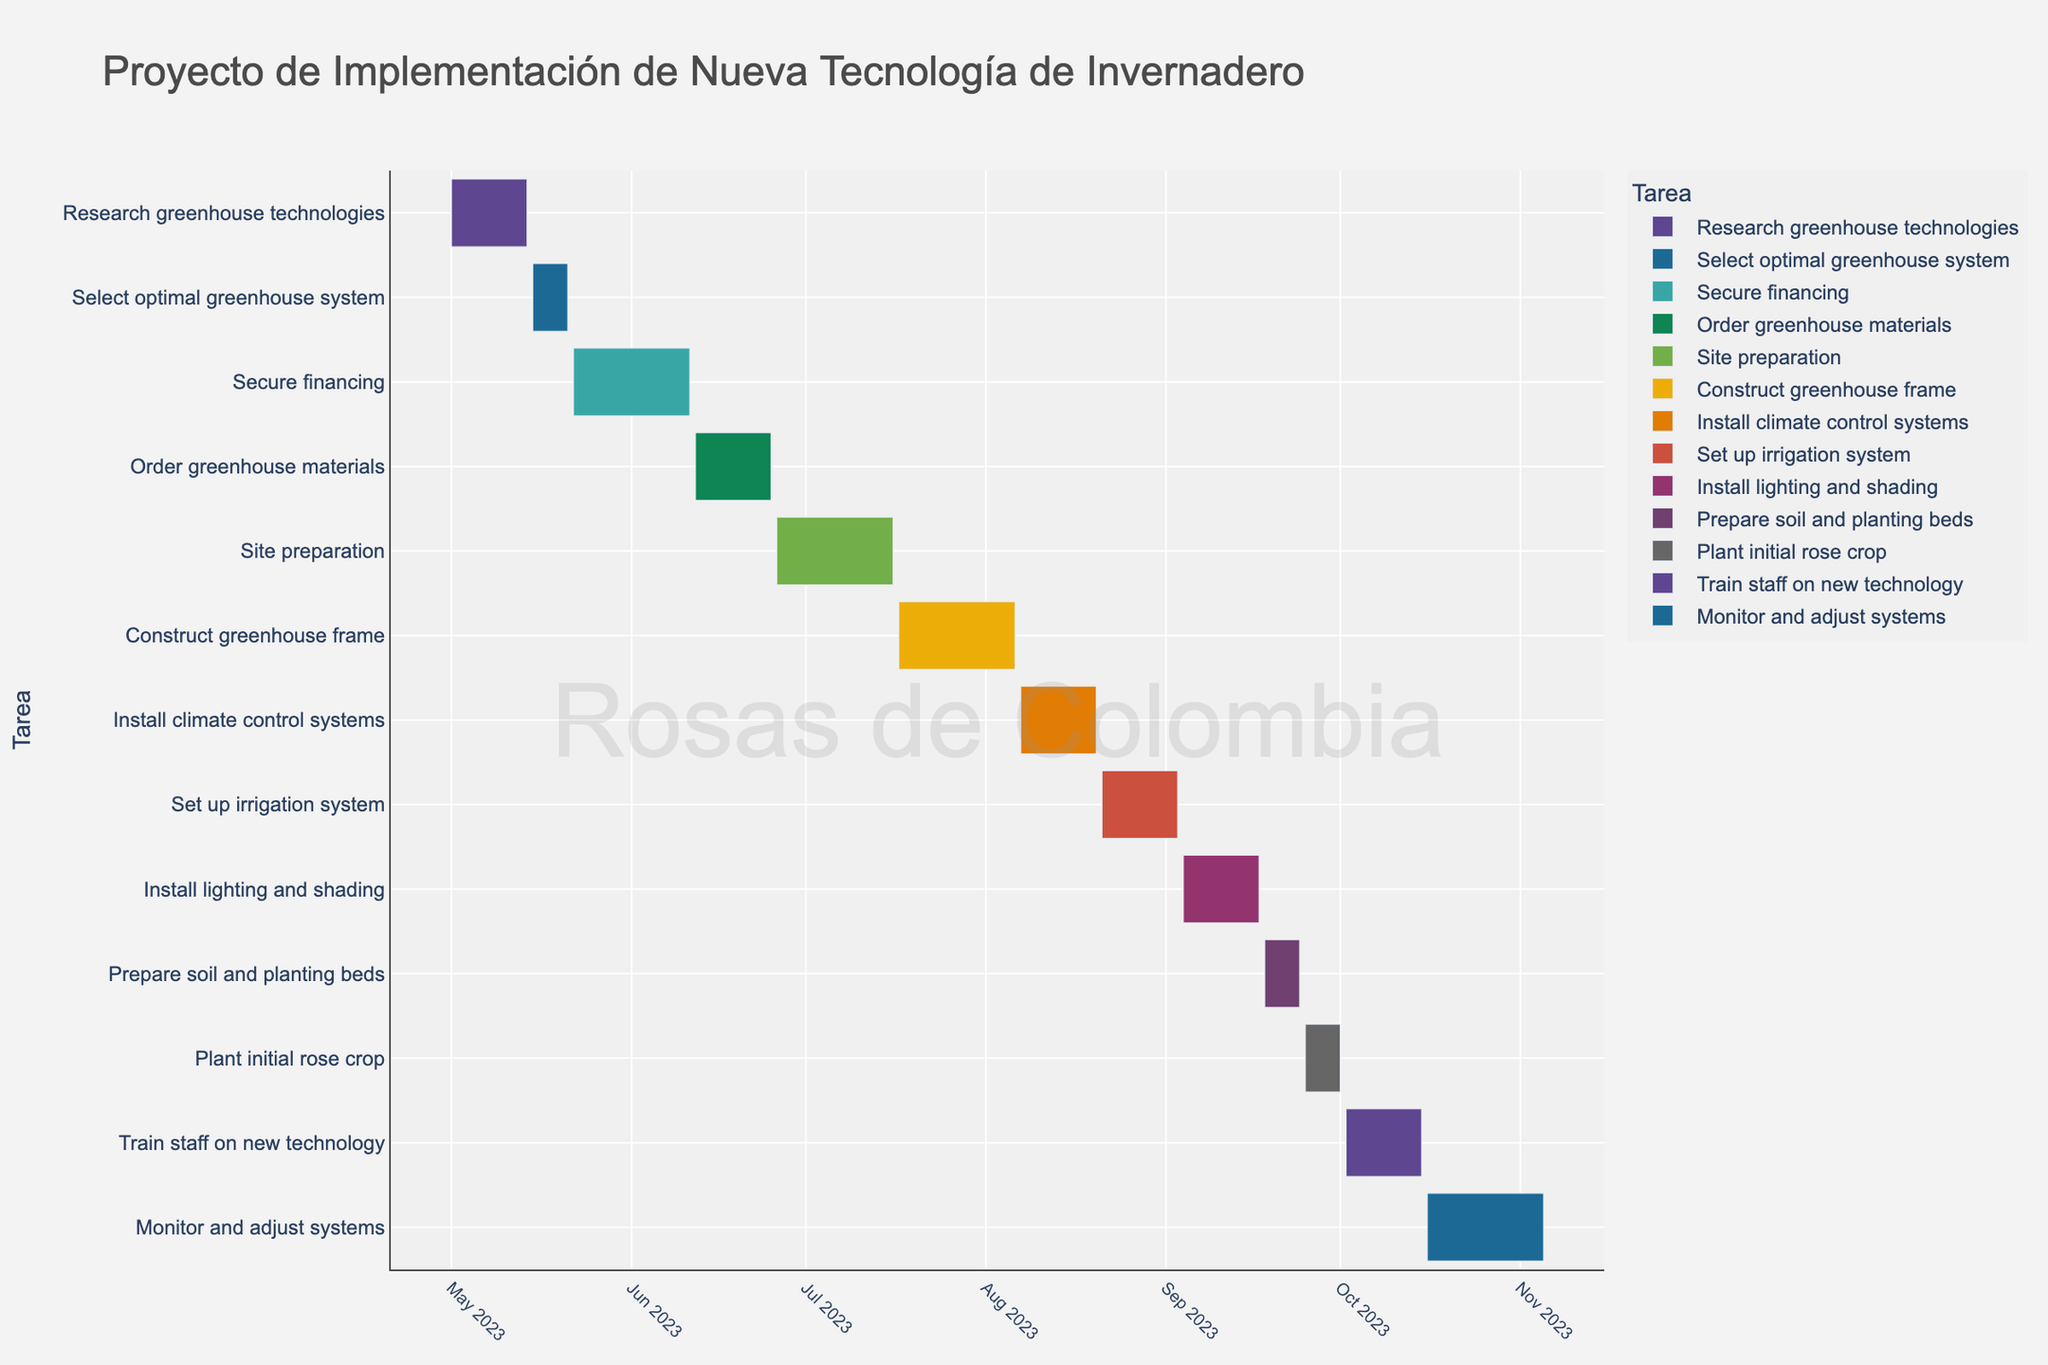What is the title of the Gantt chart? The title is usually found at the top of the chart. In this case, it's visible from the information provided in the code and corresponds to the content of the plot.
Answer: Proyecto de Implementación de Nueva Tecnología de Invernadero Which task has the shortest duration? By examining the duration of each task as displayed in the chart, you can see that "Select optimal greenhouse system," "Prepare soil and planting beds," and "Plant initial rose crop" each have a duration of 7 days.
Answer: Select optimal greenhouse system, Prepare soil and planting beds, Plant initial rose crop What are the start and end dates for the "Install lighting and shading" task? Looking at the Gantt chart, you can find the bar representing this task. The start and end dates are displayed alongside the bars.
Answer: Start: 2023-09-04, End: 2023-09-17 How many tasks involve installation or setup activities? By identifying the tasks that include words like "Install" or "Set up" in their descriptions, you count those tasks in the chart.
Answer: 4 (Install climate control systems, Set up irrigation system, Install lighting and shading, Install greenhouse frame) During which months do the most tasks take place? By looking at the timeline on the x-axis and analyzing the periods during which tasks are plotted, you can count the number of tasks for each month and identify the busiest periods.
Answer: June and September Which tasks overlap with "Site preparation"? To find overlapping tasks, look at the timeline bar for "Site preparation" and see which other tasks' bars intersect with this time period.
Answer: Order greenhouse materials, Construct greenhouse frame What is the duration of the "Monitor and adjust systems" task? Examine the Gantt chart and locate the bar for "Monitor and adjust systems." The duration is indicated directly on the chart.
Answer: 21 days Which task directly follows "Plant initial rose crop"? Find the end of the "Plant initial rose crop" bar and see which task begins immediately after it.
Answer: Train staff on new technology How are tasks differentiated visually in the chart? Observing the chart, we can see visual differentiations like different colors for each task, specific start and end dates, and unique positioning on the y-axis for each task.
Answer: By different colors and y-axis positions 